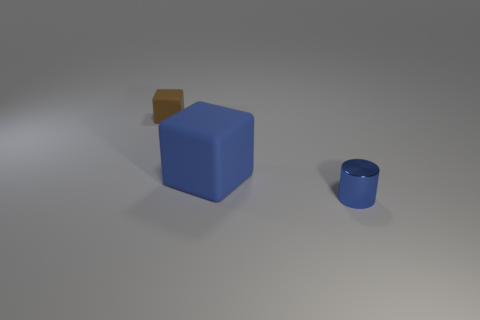Is there anything else that has the same material as the cylinder?
Provide a short and direct response. No. Are there more tiny rubber things to the left of the cylinder than blue matte spheres?
Your answer should be compact. Yes. Is there a tiny blue thing of the same shape as the big blue object?
Your answer should be very brief. No. Are the blue block and the small object that is in front of the brown rubber cube made of the same material?
Your answer should be compact. No. What is the color of the tiny matte cube?
Give a very brief answer. Brown. There is a blue thing behind the tiny thing in front of the brown block; what number of metallic cylinders are left of it?
Your answer should be compact. 0. Are there any blocks on the left side of the large blue thing?
Provide a short and direct response. Yes. How many tiny brown objects are the same material as the big block?
Keep it short and to the point. 1. How many things are either gray objects or rubber things?
Your response must be concise. 2. Is there a rubber block?
Your answer should be very brief. Yes. 